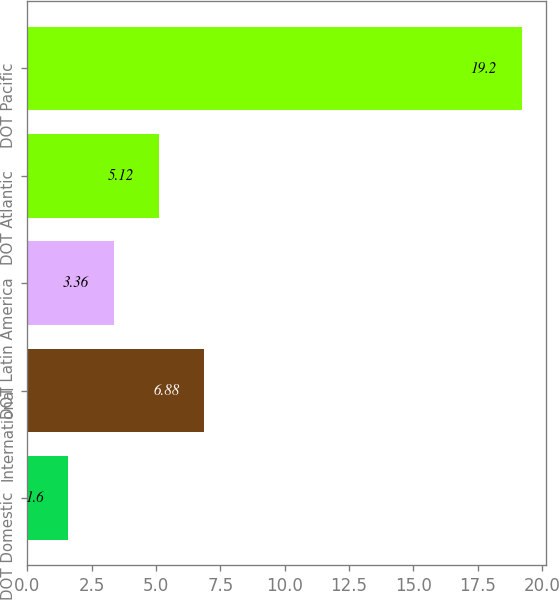<chart> <loc_0><loc_0><loc_500><loc_500><bar_chart><fcel>DOT Domestic<fcel>International<fcel>DOT Latin America<fcel>DOT Atlantic<fcel>DOT Pacific<nl><fcel>1.6<fcel>6.88<fcel>3.36<fcel>5.12<fcel>19.2<nl></chart> 